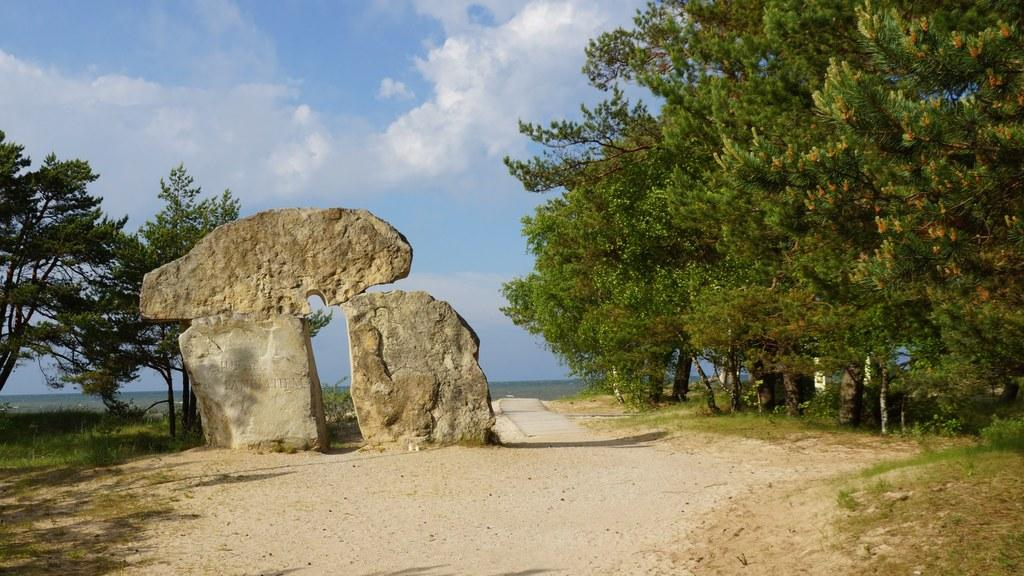What type of natural elements can be seen in the image? Rocks, trees, plants, grass, and water are visible in the image. What can be seen in the sky in the image? There are clouds in the sky in the image. Where is the ticket booth located in the image? There is no ticket booth present in the image. What type of drainage system can be seen in the image? There is no drainage system visible in the image. 